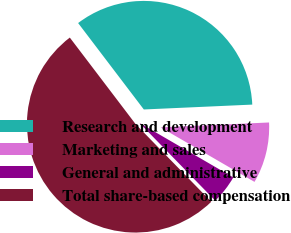Convert chart to OTSL. <chart><loc_0><loc_0><loc_500><loc_500><pie_chart><fcel>Research and development<fcel>Marketing and sales<fcel>General and administrative<fcel>Total share-based compensation<nl><fcel>34.63%<fcel>9.09%<fcel>4.33%<fcel>51.95%<nl></chart> 